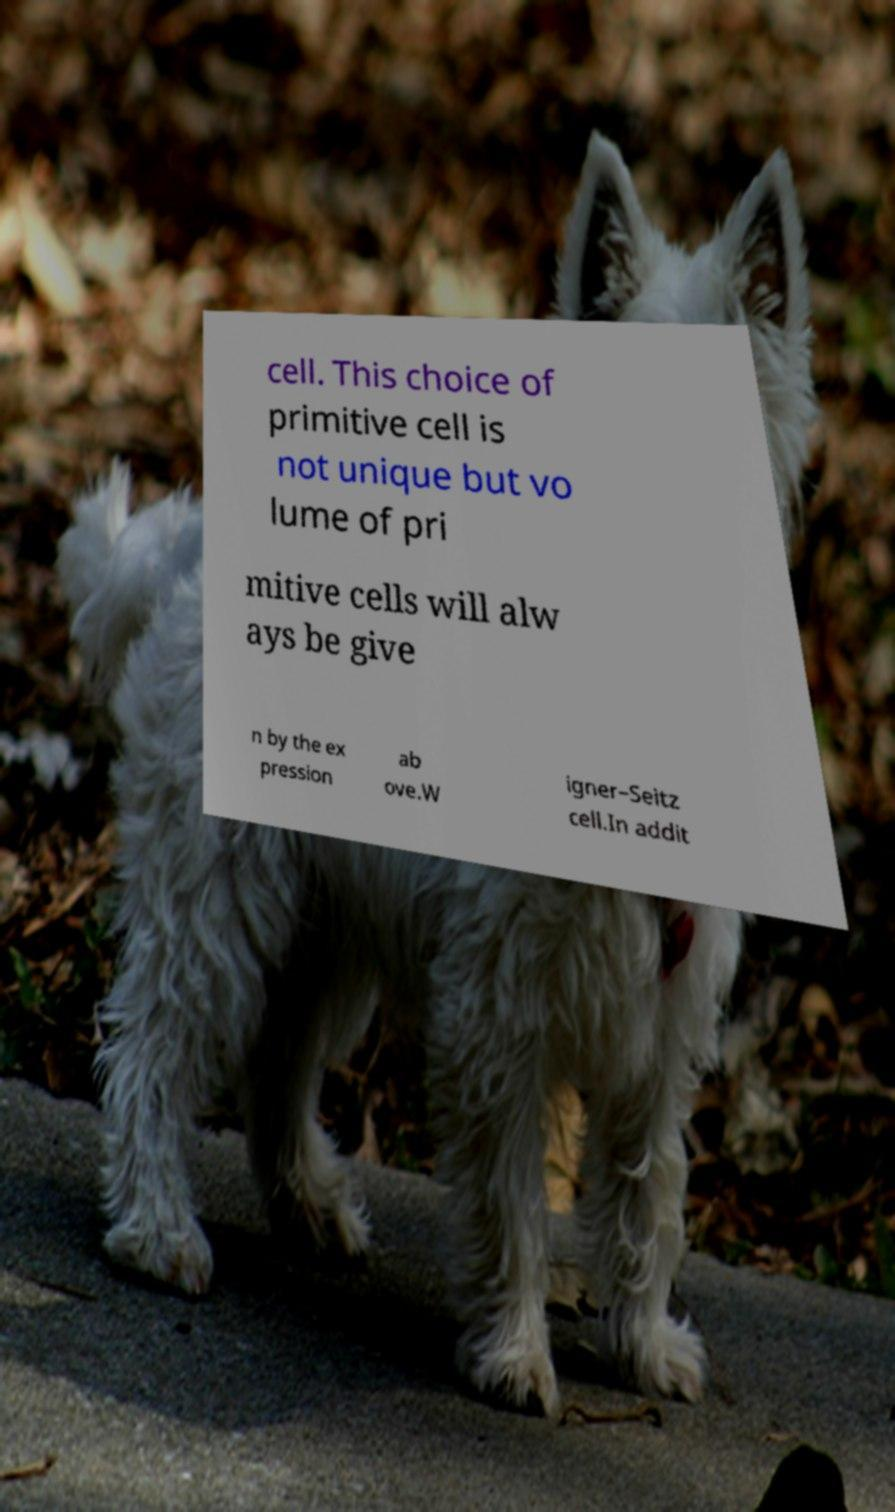What messages or text are displayed in this image? I need them in a readable, typed format. cell. This choice of primitive cell is not unique but vo lume of pri mitive cells will alw ays be give n by the ex pression ab ove.W igner–Seitz cell.In addit 